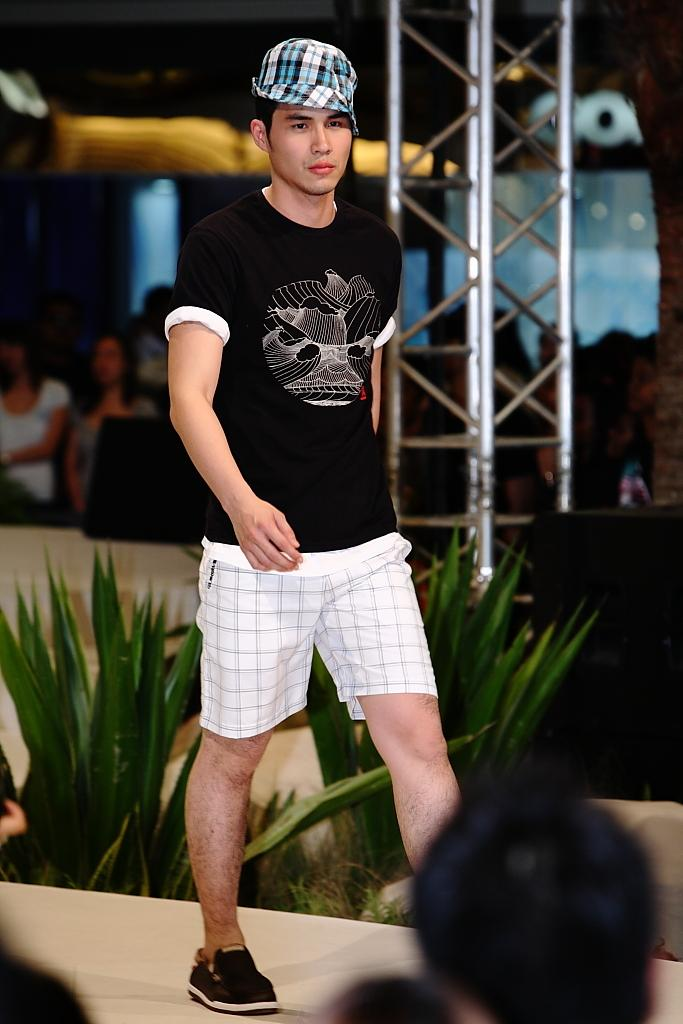What is the person in the image wearing on their upper body? The person is wearing a black shirt. What is the person in the image wearing on their lower body? The person is wearing white shorts. What can be seen in the background of the image? There are green leaves, a pole, other people, and windows in the background of the image. What type of brick is used to construct the border in the image? There is no border present in the image, and therefore no bricks can be observed. Can you tell me how many pears are visible in the image? There are no pears present in the image. 